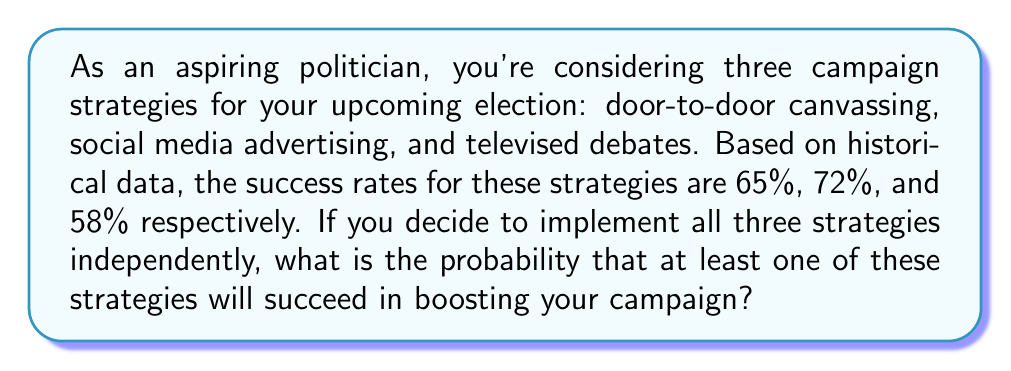Could you help me with this problem? Let's approach this step-by-step:

1) First, let's define our events:
   A: Success of door-to-door canvassing (P(A) = 0.65)
   B: Success of social media advertising (P(B) = 0.72)
   C: Success of televised debates (P(C) = 0.58)

2) We need to find the probability of at least one strategy succeeding. This is easier to calculate by finding the complement of all strategies failing.

3) Probability of all strategies failing:
   P(all fail) = P(A' ∩ B' ∩ C')
   Where A', B', and C' represent the failure of each strategy.

4) Since the strategies are independent:
   P(all fail) = P(A') × P(B') × P(C')

5) We can calculate the probability of each strategy failing:
   P(A') = 1 - P(A) = 1 - 0.65 = 0.35
   P(B') = 1 - P(B) = 1 - 0.72 = 0.28
   P(C') = 1 - P(C) = 1 - 0.58 = 0.42

6) Now we can calculate the probability of all strategies failing:
   P(all fail) = 0.35 × 0.28 × 0.42 = 0.0411

7) The probability of at least one strategy succeeding is the complement of all failing:
   P(at least one succeeds) = 1 - P(all fail)
                            = 1 - 0.0411
                            = 0.9589

8) Converting to a percentage:
   0.9589 × 100 = 95.89%
Answer: 95.89% 